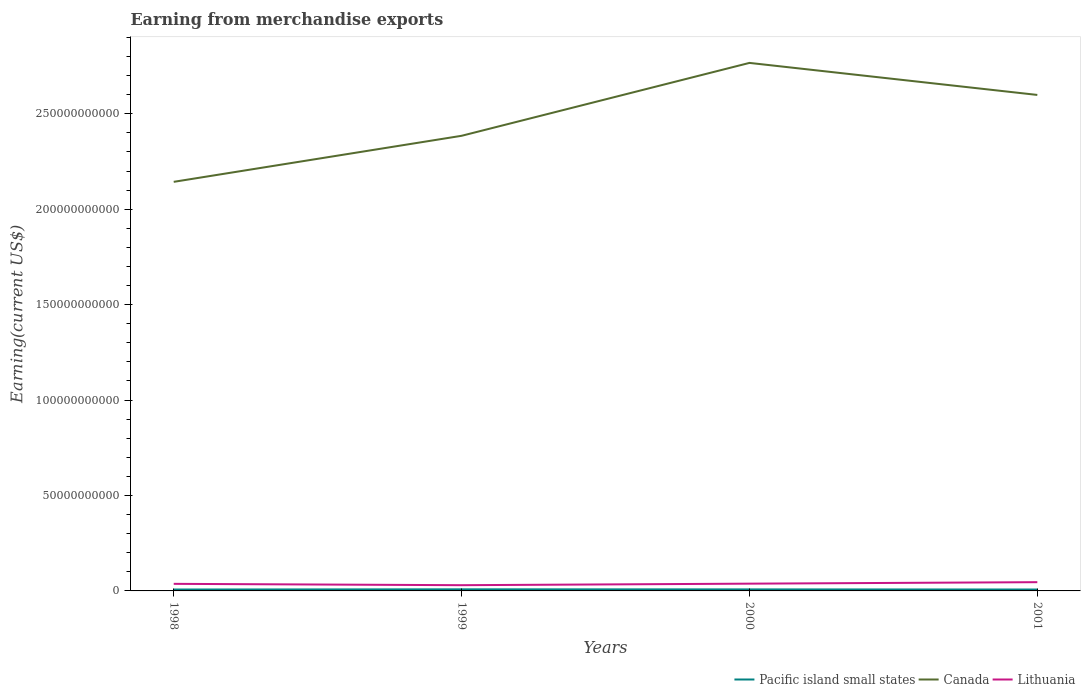How many different coloured lines are there?
Provide a succinct answer. 3. Across all years, what is the maximum amount earned from merchandise exports in Lithuania?
Your answer should be compact. 3.00e+09. What is the total amount earned from merchandise exports in Canada in the graph?
Make the answer very short. -3.82e+1. What is the difference between the highest and the second highest amount earned from merchandise exports in Lithuania?
Keep it short and to the point. 1.58e+09. How many lines are there?
Your response must be concise. 3. How many years are there in the graph?
Your answer should be very brief. 4. Are the values on the major ticks of Y-axis written in scientific E-notation?
Offer a terse response. No. Does the graph contain any zero values?
Make the answer very short. No. How are the legend labels stacked?
Provide a short and direct response. Horizontal. What is the title of the graph?
Offer a very short reply. Earning from merchandise exports. What is the label or title of the X-axis?
Offer a very short reply. Years. What is the label or title of the Y-axis?
Your response must be concise. Earning(current US$). What is the Earning(current US$) of Pacific island small states in 1998?
Your response must be concise. 7.33e+08. What is the Earning(current US$) of Canada in 1998?
Your answer should be very brief. 2.14e+11. What is the Earning(current US$) in Lithuania in 1998?
Give a very brief answer. 3.71e+09. What is the Earning(current US$) in Pacific island small states in 1999?
Make the answer very short. 8.36e+08. What is the Earning(current US$) of Canada in 1999?
Give a very brief answer. 2.38e+11. What is the Earning(current US$) in Lithuania in 1999?
Your answer should be very brief. 3.00e+09. What is the Earning(current US$) of Pacific island small states in 2000?
Keep it short and to the point. 8.00e+08. What is the Earning(current US$) of Canada in 2000?
Your answer should be very brief. 2.77e+11. What is the Earning(current US$) in Lithuania in 2000?
Ensure brevity in your answer.  3.81e+09. What is the Earning(current US$) in Pacific island small states in 2001?
Make the answer very short. 7.34e+08. What is the Earning(current US$) in Canada in 2001?
Ensure brevity in your answer.  2.60e+11. What is the Earning(current US$) in Lithuania in 2001?
Ensure brevity in your answer.  4.58e+09. Across all years, what is the maximum Earning(current US$) in Pacific island small states?
Your answer should be very brief. 8.36e+08. Across all years, what is the maximum Earning(current US$) of Canada?
Offer a very short reply. 2.77e+11. Across all years, what is the maximum Earning(current US$) of Lithuania?
Ensure brevity in your answer.  4.58e+09. Across all years, what is the minimum Earning(current US$) of Pacific island small states?
Provide a succinct answer. 7.33e+08. Across all years, what is the minimum Earning(current US$) in Canada?
Offer a very short reply. 2.14e+11. Across all years, what is the minimum Earning(current US$) in Lithuania?
Keep it short and to the point. 3.00e+09. What is the total Earning(current US$) in Pacific island small states in the graph?
Ensure brevity in your answer.  3.10e+09. What is the total Earning(current US$) of Canada in the graph?
Offer a terse response. 9.89e+11. What is the total Earning(current US$) in Lithuania in the graph?
Your answer should be compact. 1.51e+1. What is the difference between the Earning(current US$) of Pacific island small states in 1998 and that in 1999?
Provide a succinct answer. -1.02e+08. What is the difference between the Earning(current US$) of Canada in 1998 and that in 1999?
Your answer should be compact. -2.41e+1. What is the difference between the Earning(current US$) in Lithuania in 1998 and that in 1999?
Offer a very short reply. 7.06e+08. What is the difference between the Earning(current US$) in Pacific island small states in 1998 and that in 2000?
Provide a succinct answer. -6.64e+07. What is the difference between the Earning(current US$) in Canada in 1998 and that in 2000?
Provide a short and direct response. -6.23e+1. What is the difference between the Earning(current US$) of Lithuania in 1998 and that in 2000?
Offer a very short reply. -1.00e+08. What is the difference between the Earning(current US$) of Pacific island small states in 1998 and that in 2001?
Your response must be concise. -3.61e+05. What is the difference between the Earning(current US$) of Canada in 1998 and that in 2001?
Provide a short and direct response. -4.55e+1. What is the difference between the Earning(current US$) in Lithuania in 1998 and that in 2001?
Make the answer very short. -8.73e+08. What is the difference between the Earning(current US$) of Pacific island small states in 1999 and that in 2000?
Make the answer very short. 3.60e+07. What is the difference between the Earning(current US$) in Canada in 1999 and that in 2000?
Give a very brief answer. -3.82e+1. What is the difference between the Earning(current US$) in Lithuania in 1999 and that in 2000?
Your response must be concise. -8.06e+08. What is the difference between the Earning(current US$) of Pacific island small states in 1999 and that in 2001?
Give a very brief answer. 1.02e+08. What is the difference between the Earning(current US$) in Canada in 1999 and that in 2001?
Provide a short and direct response. -2.14e+1. What is the difference between the Earning(current US$) of Lithuania in 1999 and that in 2001?
Make the answer very short. -1.58e+09. What is the difference between the Earning(current US$) of Pacific island small states in 2000 and that in 2001?
Keep it short and to the point. 6.61e+07. What is the difference between the Earning(current US$) of Canada in 2000 and that in 2001?
Your answer should be compact. 1.68e+1. What is the difference between the Earning(current US$) of Lithuania in 2000 and that in 2001?
Offer a terse response. -7.73e+08. What is the difference between the Earning(current US$) of Pacific island small states in 1998 and the Earning(current US$) of Canada in 1999?
Your answer should be very brief. -2.38e+11. What is the difference between the Earning(current US$) in Pacific island small states in 1998 and the Earning(current US$) in Lithuania in 1999?
Ensure brevity in your answer.  -2.27e+09. What is the difference between the Earning(current US$) in Canada in 1998 and the Earning(current US$) in Lithuania in 1999?
Ensure brevity in your answer.  2.11e+11. What is the difference between the Earning(current US$) in Pacific island small states in 1998 and the Earning(current US$) in Canada in 2000?
Provide a short and direct response. -2.76e+11. What is the difference between the Earning(current US$) in Pacific island small states in 1998 and the Earning(current US$) in Lithuania in 2000?
Ensure brevity in your answer.  -3.08e+09. What is the difference between the Earning(current US$) in Canada in 1998 and the Earning(current US$) in Lithuania in 2000?
Your answer should be compact. 2.11e+11. What is the difference between the Earning(current US$) of Pacific island small states in 1998 and the Earning(current US$) of Canada in 2001?
Offer a terse response. -2.59e+11. What is the difference between the Earning(current US$) in Pacific island small states in 1998 and the Earning(current US$) in Lithuania in 2001?
Your response must be concise. -3.85e+09. What is the difference between the Earning(current US$) of Canada in 1998 and the Earning(current US$) of Lithuania in 2001?
Ensure brevity in your answer.  2.10e+11. What is the difference between the Earning(current US$) of Pacific island small states in 1999 and the Earning(current US$) of Canada in 2000?
Make the answer very short. -2.76e+11. What is the difference between the Earning(current US$) in Pacific island small states in 1999 and the Earning(current US$) in Lithuania in 2000?
Offer a very short reply. -2.97e+09. What is the difference between the Earning(current US$) of Canada in 1999 and the Earning(current US$) of Lithuania in 2000?
Give a very brief answer. 2.35e+11. What is the difference between the Earning(current US$) of Pacific island small states in 1999 and the Earning(current US$) of Canada in 2001?
Ensure brevity in your answer.  -2.59e+11. What is the difference between the Earning(current US$) in Pacific island small states in 1999 and the Earning(current US$) in Lithuania in 2001?
Offer a very short reply. -3.75e+09. What is the difference between the Earning(current US$) in Canada in 1999 and the Earning(current US$) in Lithuania in 2001?
Offer a terse response. 2.34e+11. What is the difference between the Earning(current US$) in Pacific island small states in 2000 and the Earning(current US$) in Canada in 2001?
Your answer should be compact. -2.59e+11. What is the difference between the Earning(current US$) in Pacific island small states in 2000 and the Earning(current US$) in Lithuania in 2001?
Keep it short and to the point. -3.78e+09. What is the difference between the Earning(current US$) of Canada in 2000 and the Earning(current US$) of Lithuania in 2001?
Your answer should be compact. 2.72e+11. What is the average Earning(current US$) of Pacific island small states per year?
Offer a very short reply. 7.76e+08. What is the average Earning(current US$) of Canada per year?
Make the answer very short. 2.47e+11. What is the average Earning(current US$) of Lithuania per year?
Provide a succinct answer. 3.78e+09. In the year 1998, what is the difference between the Earning(current US$) of Pacific island small states and Earning(current US$) of Canada?
Offer a terse response. -2.14e+11. In the year 1998, what is the difference between the Earning(current US$) of Pacific island small states and Earning(current US$) of Lithuania?
Offer a very short reply. -2.98e+09. In the year 1998, what is the difference between the Earning(current US$) in Canada and Earning(current US$) in Lithuania?
Provide a short and direct response. 2.11e+11. In the year 1999, what is the difference between the Earning(current US$) of Pacific island small states and Earning(current US$) of Canada?
Provide a succinct answer. -2.38e+11. In the year 1999, what is the difference between the Earning(current US$) of Pacific island small states and Earning(current US$) of Lithuania?
Your answer should be very brief. -2.17e+09. In the year 1999, what is the difference between the Earning(current US$) in Canada and Earning(current US$) in Lithuania?
Your answer should be compact. 2.35e+11. In the year 2000, what is the difference between the Earning(current US$) in Pacific island small states and Earning(current US$) in Canada?
Your response must be concise. -2.76e+11. In the year 2000, what is the difference between the Earning(current US$) of Pacific island small states and Earning(current US$) of Lithuania?
Your answer should be compact. -3.01e+09. In the year 2000, what is the difference between the Earning(current US$) in Canada and Earning(current US$) in Lithuania?
Give a very brief answer. 2.73e+11. In the year 2001, what is the difference between the Earning(current US$) of Pacific island small states and Earning(current US$) of Canada?
Make the answer very short. -2.59e+11. In the year 2001, what is the difference between the Earning(current US$) in Pacific island small states and Earning(current US$) in Lithuania?
Offer a terse response. -3.85e+09. In the year 2001, what is the difference between the Earning(current US$) of Canada and Earning(current US$) of Lithuania?
Keep it short and to the point. 2.55e+11. What is the ratio of the Earning(current US$) in Pacific island small states in 1998 to that in 1999?
Provide a short and direct response. 0.88. What is the ratio of the Earning(current US$) of Canada in 1998 to that in 1999?
Your answer should be compact. 0.9. What is the ratio of the Earning(current US$) in Lithuania in 1998 to that in 1999?
Your response must be concise. 1.24. What is the ratio of the Earning(current US$) of Pacific island small states in 1998 to that in 2000?
Offer a very short reply. 0.92. What is the ratio of the Earning(current US$) of Canada in 1998 to that in 2000?
Ensure brevity in your answer.  0.77. What is the ratio of the Earning(current US$) of Lithuania in 1998 to that in 2000?
Give a very brief answer. 0.97. What is the ratio of the Earning(current US$) of Canada in 1998 to that in 2001?
Your answer should be compact. 0.82. What is the ratio of the Earning(current US$) in Lithuania in 1998 to that in 2001?
Your answer should be very brief. 0.81. What is the ratio of the Earning(current US$) of Pacific island small states in 1999 to that in 2000?
Provide a succinct answer. 1.04. What is the ratio of the Earning(current US$) of Canada in 1999 to that in 2000?
Your response must be concise. 0.86. What is the ratio of the Earning(current US$) of Lithuania in 1999 to that in 2000?
Make the answer very short. 0.79. What is the ratio of the Earning(current US$) of Pacific island small states in 1999 to that in 2001?
Make the answer very short. 1.14. What is the ratio of the Earning(current US$) in Canada in 1999 to that in 2001?
Your response must be concise. 0.92. What is the ratio of the Earning(current US$) in Lithuania in 1999 to that in 2001?
Your answer should be very brief. 0.66. What is the ratio of the Earning(current US$) of Pacific island small states in 2000 to that in 2001?
Provide a short and direct response. 1.09. What is the ratio of the Earning(current US$) in Canada in 2000 to that in 2001?
Offer a terse response. 1.06. What is the ratio of the Earning(current US$) of Lithuania in 2000 to that in 2001?
Provide a short and direct response. 0.83. What is the difference between the highest and the second highest Earning(current US$) of Pacific island small states?
Keep it short and to the point. 3.60e+07. What is the difference between the highest and the second highest Earning(current US$) of Canada?
Give a very brief answer. 1.68e+1. What is the difference between the highest and the second highest Earning(current US$) in Lithuania?
Offer a terse response. 7.73e+08. What is the difference between the highest and the lowest Earning(current US$) of Pacific island small states?
Make the answer very short. 1.02e+08. What is the difference between the highest and the lowest Earning(current US$) of Canada?
Make the answer very short. 6.23e+1. What is the difference between the highest and the lowest Earning(current US$) of Lithuania?
Offer a very short reply. 1.58e+09. 